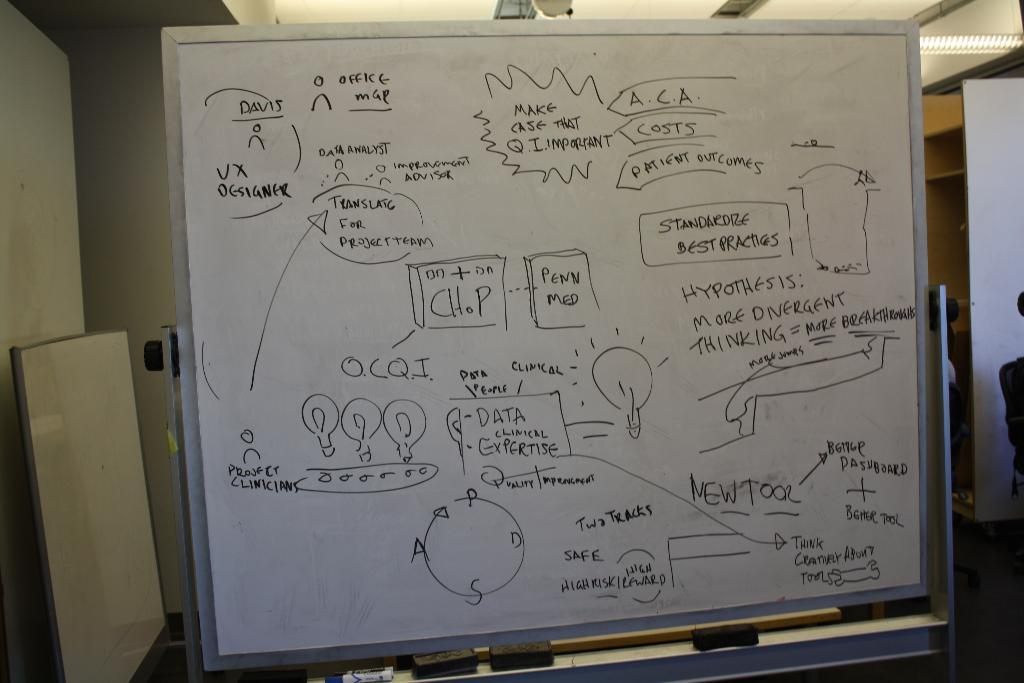<image>
Describe the image concisely. A white board with words and drawings, the letters ACA can be seen. 